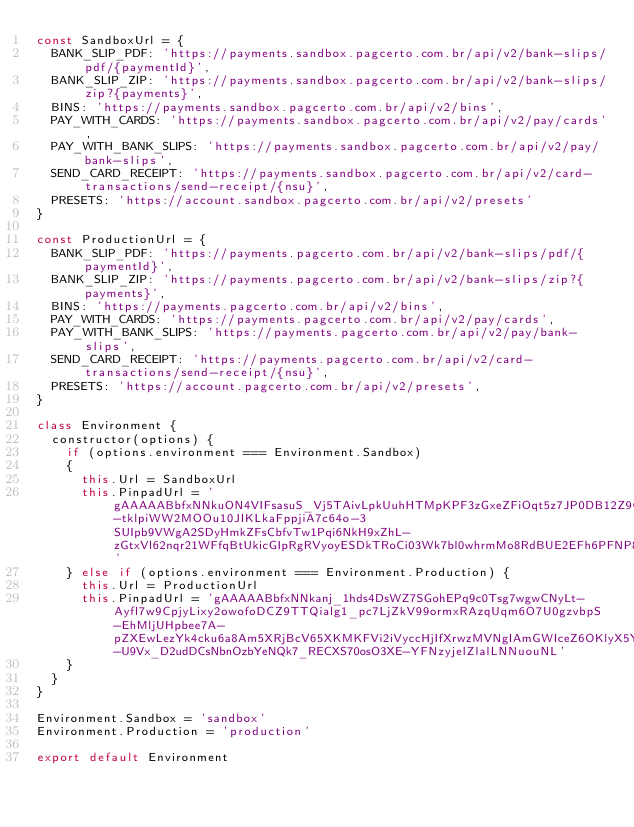<code> <loc_0><loc_0><loc_500><loc_500><_JavaScript_>const SandboxUrl = {
  BANK_SLIP_PDF: 'https://payments.sandbox.pagcerto.com.br/api/v2/bank-slips/pdf/{paymentId}',
  BANK_SLIP_ZIP: 'https://payments.sandbox.pagcerto.com.br/api/v2/bank-slips/zip?{payments}',
  BINS: 'https://payments.sandbox.pagcerto.com.br/api/v2/bins',
  PAY_WITH_CARDS: 'https://payments.sandbox.pagcerto.com.br/api/v2/pay/cards',
  PAY_WITH_BANK_SLIPS: 'https://payments.sandbox.pagcerto.com.br/api/v2/pay/bank-slips',
  SEND_CARD_RECEIPT: 'https://payments.sandbox.pagcerto.com.br/api/v2/card-transactions/send-receipt/{nsu}',
  PRESETS: 'https://account.sandbox.pagcerto.com.br/api/v2/presets'
}

const ProductionUrl = {
  BANK_SLIP_PDF: 'https://payments.pagcerto.com.br/api/v2/bank-slips/pdf/{paymentId}',
  BANK_SLIP_ZIP: 'https://payments.pagcerto.com.br/api/v2/bank-slips/zip?{payments}',
  BINS: 'https://payments.pagcerto.com.br/api/v2/bins',
  PAY_WITH_CARDS: 'https://payments.pagcerto.com.br/api/v2/pay/cards',
  PAY_WITH_BANK_SLIPS: 'https://payments.pagcerto.com.br/api/v2/pay/bank-slips',
  SEND_CARD_RECEIPT: 'https://payments.pagcerto.com.br/api/v2/card-transactions/send-receipt/{nsu}',
  PRESETS: 'https://account.pagcerto.com.br/api/v2/presets',
}

class Environment {
  constructor(options) {
    if (options.environment === Environment.Sandbox)
    {
      this.Url = SandboxUrl
      this.PinpadUrl = 'gAAAAABbfxNNkuON4VIFsasuS_Vj5TAivLpkUuhHTMpKPF3zGxeZFiOqt5z7JP0DB12Z9GteERV7IyUDMgYdigudFXN2IP997nvgGMUZQhVILaHD0SagyUH98BMsEetbS6GY4bE9ougf3XJ3Zyh5HCRWOhE4xwzivQ5Bc9czIdNikh0pu1uGis3mLr8t-tklpiWW2MOOu10JIKLkaFppjiA7c64o-3SUIpb9VWgA2SDyHmkZFsCbfvTw1Pqi6NkH9xZhL-zGtxVl62nqr21WFfqBtUkicGIpRgRVyoyESDkTRoCi03Wk7bl0whrmMo8RdBUE2EFh6PFNP8tmacbQD61cKh7xt6xRHAX8ZnAwJ0S3JADqQP1rdHh2Y75eaRW01BKTV3i2qad_'
    } else if (options.environment === Environment.Production) {
      this.Url = ProductionUrl
      this.PinpadUrl = 'gAAAAABbfxNNkanj_1hds4DsWZ7SGohEPq9c0Tsg7wgwCNyLt-Ayfl7w9CpjyLixy2owofoDCZ9TTQialg1_pc7LjZkV99ormxRAzqUqm6O7U0gzvbpS-EhMljUHpbee7A-pZXEwLezYk4cku6a8Am5XRjBcV65XKMKFVi2iVyccHjIfXrwzMVNgIAmGWIceZ6OKlyX5Y_3R2_s9JkpMGFY1PuFrEYqs1uI_vs010fk8iYXfw98_Tym2eVOf7jsujGmW9A4GNLN1kDH93IZNVhr_aKtHIr6MhQwTtRX1UJbxIeosCe5o0G0ruSUJuOpipalIm833IU86RkhB-U9Vx_D2udDCsNbnOzbYeNQk7_RECXS70osO3XE-YFNzyjelZlalLNNuouNL'
    }
  }
}

Environment.Sandbox = 'sandbox'
Environment.Production = 'production'

export default Environment
</code> 